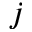<formula> <loc_0><loc_0><loc_500><loc_500>j</formula> 